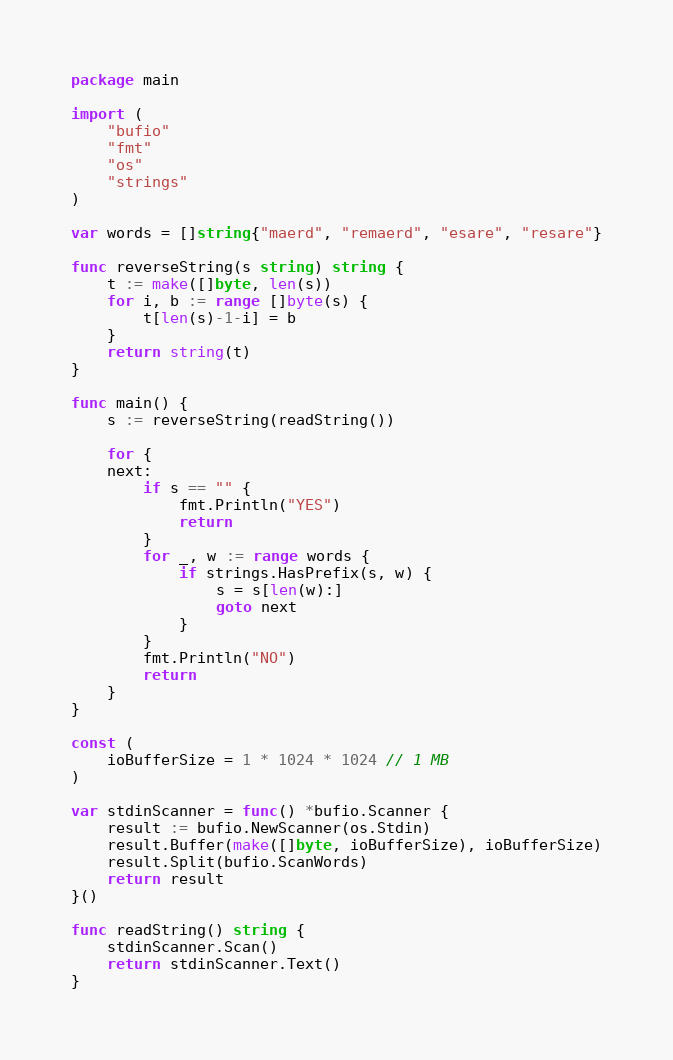<code> <loc_0><loc_0><loc_500><loc_500><_Go_>package main

import (
	"bufio"
	"fmt"
	"os"
	"strings"
)

var words = []string{"maerd", "remaerd", "esare", "resare"}

func reverseString(s string) string {
	t := make([]byte, len(s))
	for i, b := range []byte(s) {
		t[len(s)-1-i] = b
	}
	return string(t)
}

func main() {
	s := reverseString(readString())

	for {
	next:
		if s == "" {
			fmt.Println("YES")
			return
		}
		for _, w := range words {
			if strings.HasPrefix(s, w) {
				s = s[len(w):]
				goto next
			}
		}
		fmt.Println("NO")
		return
	}
}

const (
	ioBufferSize = 1 * 1024 * 1024 // 1 MB
)

var stdinScanner = func() *bufio.Scanner {
	result := bufio.NewScanner(os.Stdin)
	result.Buffer(make([]byte, ioBufferSize), ioBufferSize)
	result.Split(bufio.ScanWords)
	return result
}()

func readString() string {
	stdinScanner.Scan()
	return stdinScanner.Text()
}
</code> 